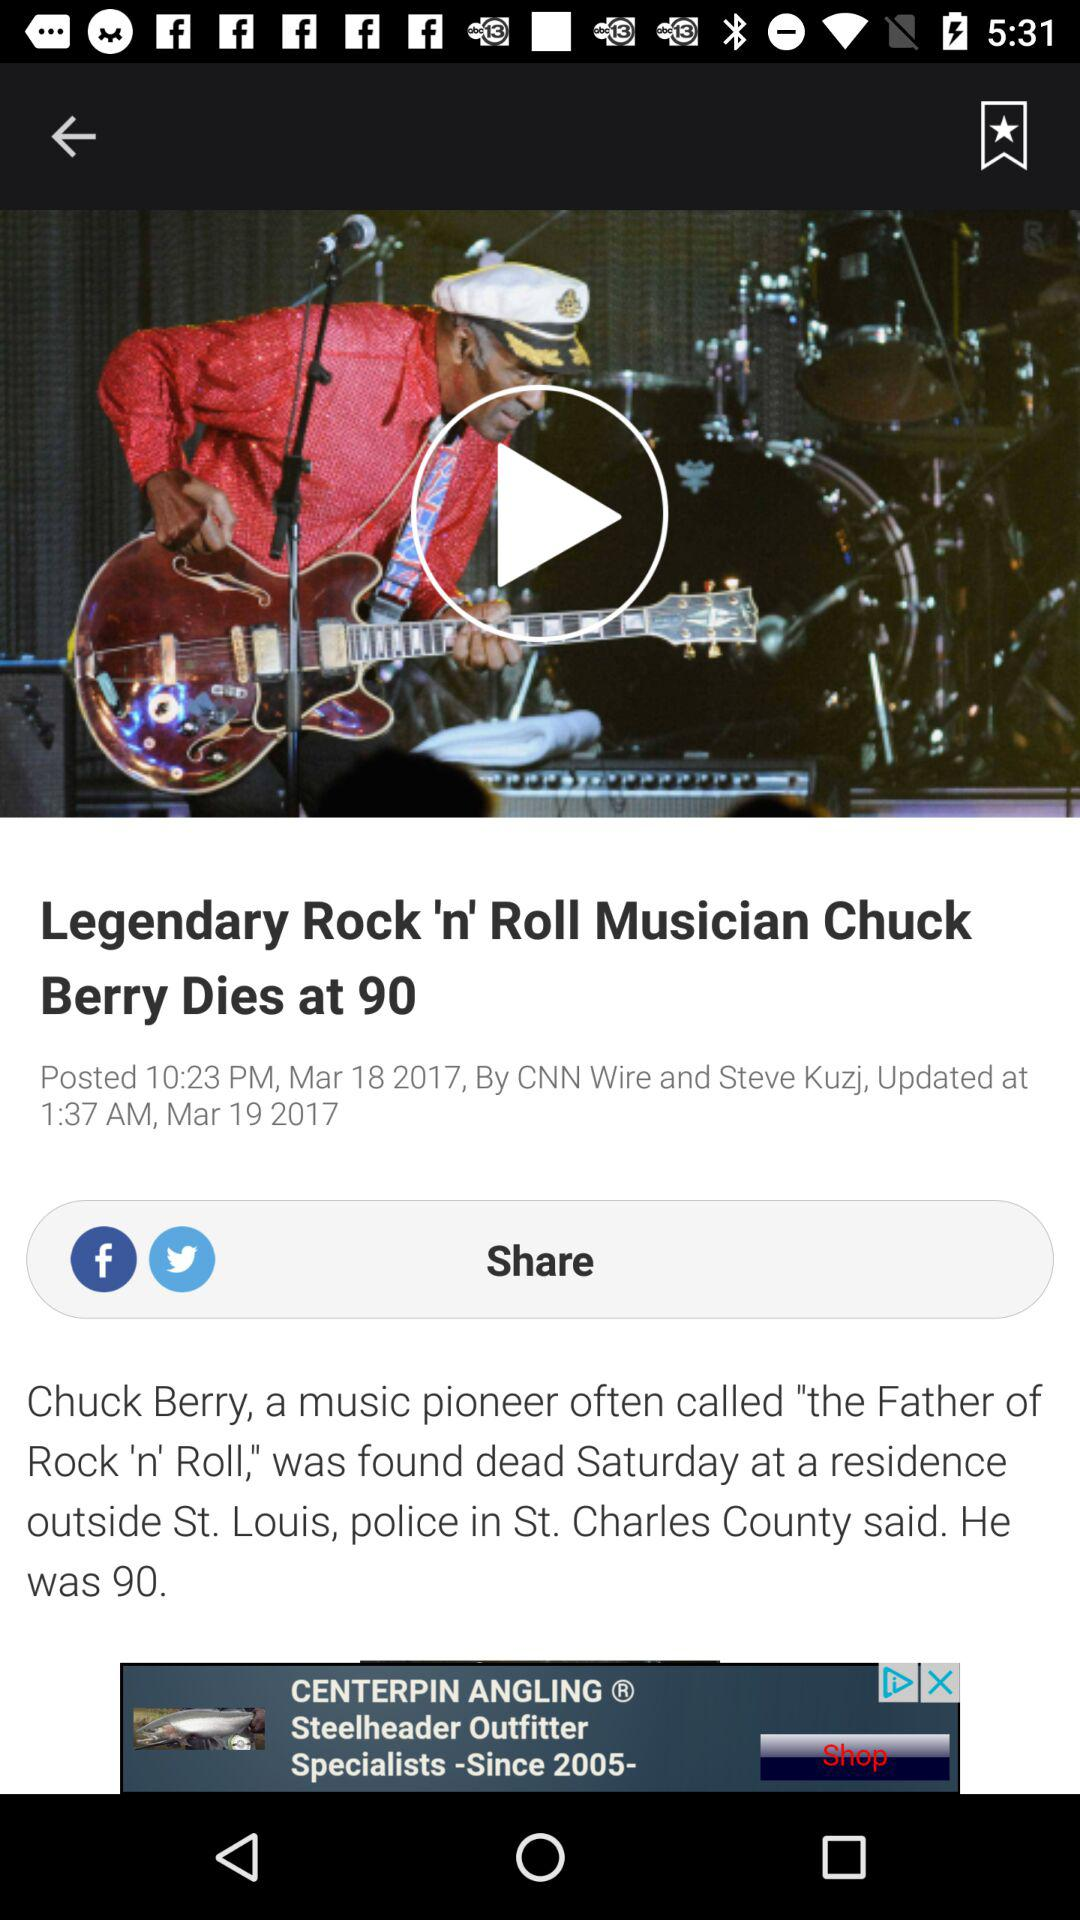What is the news channel name? The news channel name is "CNN". 